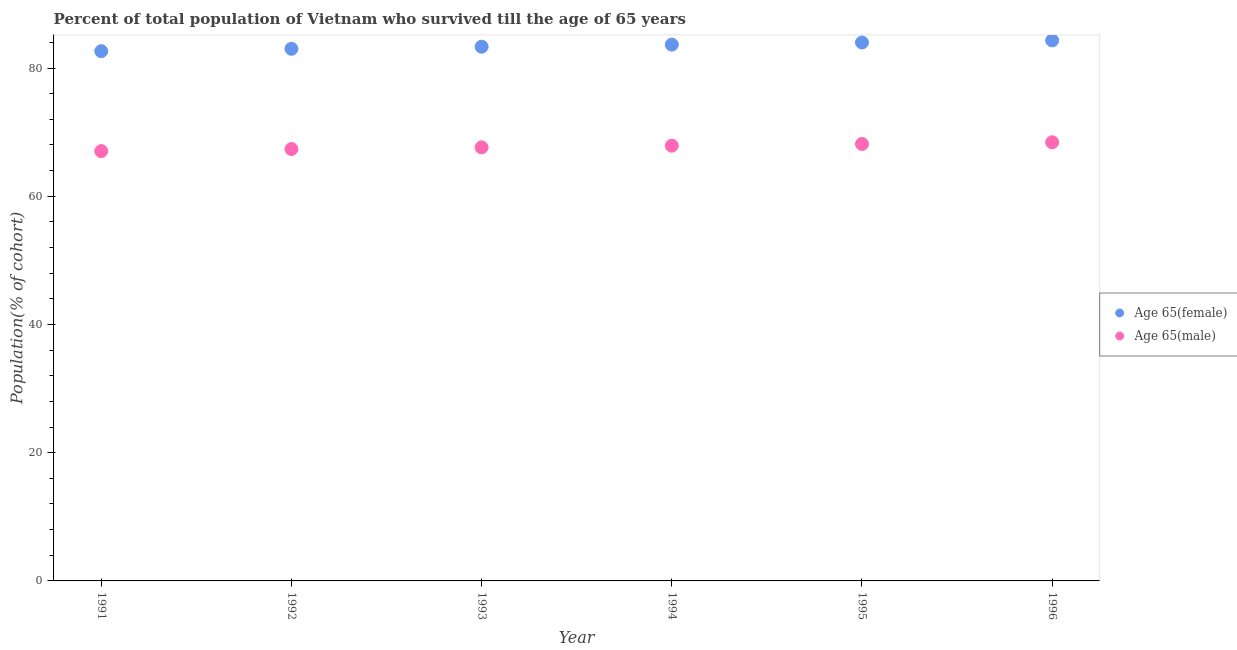Is the number of dotlines equal to the number of legend labels?
Keep it short and to the point. Yes. What is the percentage of female population who survived till age of 65 in 1995?
Your answer should be very brief. 83.99. Across all years, what is the maximum percentage of female population who survived till age of 65?
Make the answer very short. 84.31. Across all years, what is the minimum percentage of male population who survived till age of 65?
Your answer should be very brief. 67.05. In which year was the percentage of female population who survived till age of 65 maximum?
Keep it short and to the point. 1996. In which year was the percentage of female population who survived till age of 65 minimum?
Offer a very short reply. 1991. What is the total percentage of male population who survived till age of 65 in the graph?
Give a very brief answer. 406.53. What is the difference between the percentage of male population who survived till age of 65 in 1991 and that in 1995?
Provide a short and direct response. -1.11. What is the difference between the percentage of female population who survived till age of 65 in 1996 and the percentage of male population who survived till age of 65 in 1991?
Offer a terse response. 17.27. What is the average percentage of female population who survived till age of 65 per year?
Keep it short and to the point. 83.49. In the year 1996, what is the difference between the percentage of male population who survived till age of 65 and percentage of female population who survived till age of 65?
Ensure brevity in your answer.  -15.89. In how many years, is the percentage of male population who survived till age of 65 greater than 24 %?
Your response must be concise. 6. What is the ratio of the percentage of male population who survived till age of 65 in 1994 to that in 1996?
Your response must be concise. 0.99. Is the percentage of female population who survived till age of 65 in 1994 less than that in 1996?
Make the answer very short. Yes. Is the difference between the percentage of female population who survived till age of 65 in 1992 and 1995 greater than the difference between the percentage of male population who survived till age of 65 in 1992 and 1995?
Provide a short and direct response. No. What is the difference between the highest and the second highest percentage of male population who survived till age of 65?
Your response must be concise. 0.26. What is the difference between the highest and the lowest percentage of male population who survived till age of 65?
Your response must be concise. 1.38. Is the sum of the percentage of female population who survived till age of 65 in 1993 and 1996 greater than the maximum percentage of male population who survived till age of 65 across all years?
Your answer should be very brief. Yes. Is the percentage of male population who survived till age of 65 strictly less than the percentage of female population who survived till age of 65 over the years?
Keep it short and to the point. Yes. What is the difference between two consecutive major ticks on the Y-axis?
Give a very brief answer. 20. Are the values on the major ticks of Y-axis written in scientific E-notation?
Keep it short and to the point. No. Does the graph contain any zero values?
Keep it short and to the point. No. Does the graph contain grids?
Offer a terse response. No. How many legend labels are there?
Your answer should be compact. 2. What is the title of the graph?
Offer a very short reply. Percent of total population of Vietnam who survived till the age of 65 years. Does "Official aid received" appear as one of the legend labels in the graph?
Your answer should be compact. No. What is the label or title of the X-axis?
Make the answer very short. Year. What is the label or title of the Y-axis?
Offer a terse response. Population(% of cohort). What is the Population(% of cohort) of Age 65(female) in 1991?
Offer a terse response. 82.63. What is the Population(% of cohort) of Age 65(male) in 1991?
Ensure brevity in your answer.  67.05. What is the Population(% of cohort) in Age 65(female) in 1992?
Keep it short and to the point. 83. What is the Population(% of cohort) of Age 65(male) in 1992?
Your response must be concise. 67.37. What is the Population(% of cohort) in Age 65(female) in 1993?
Make the answer very short. 83.33. What is the Population(% of cohort) in Age 65(male) in 1993?
Provide a short and direct response. 67.63. What is the Population(% of cohort) in Age 65(female) in 1994?
Give a very brief answer. 83.66. What is the Population(% of cohort) in Age 65(male) in 1994?
Give a very brief answer. 67.9. What is the Population(% of cohort) in Age 65(female) in 1995?
Your response must be concise. 83.99. What is the Population(% of cohort) of Age 65(male) in 1995?
Keep it short and to the point. 68.16. What is the Population(% of cohort) of Age 65(female) in 1996?
Your response must be concise. 84.31. What is the Population(% of cohort) of Age 65(male) in 1996?
Offer a terse response. 68.42. Across all years, what is the maximum Population(% of cohort) of Age 65(female)?
Provide a short and direct response. 84.31. Across all years, what is the maximum Population(% of cohort) in Age 65(male)?
Ensure brevity in your answer.  68.42. Across all years, what is the minimum Population(% of cohort) of Age 65(female)?
Offer a very short reply. 82.63. Across all years, what is the minimum Population(% of cohort) in Age 65(male)?
Provide a short and direct response. 67.05. What is the total Population(% of cohort) of Age 65(female) in the graph?
Ensure brevity in your answer.  500.93. What is the total Population(% of cohort) of Age 65(male) in the graph?
Your answer should be compact. 406.53. What is the difference between the Population(% of cohort) of Age 65(female) in 1991 and that in 1992?
Make the answer very short. -0.37. What is the difference between the Population(% of cohort) in Age 65(male) in 1991 and that in 1992?
Make the answer very short. -0.32. What is the difference between the Population(% of cohort) in Age 65(female) in 1991 and that in 1993?
Provide a short and direct response. -0.7. What is the difference between the Population(% of cohort) in Age 65(male) in 1991 and that in 1993?
Your response must be concise. -0.58. What is the difference between the Population(% of cohort) in Age 65(female) in 1991 and that in 1994?
Offer a terse response. -1.02. What is the difference between the Population(% of cohort) of Age 65(male) in 1991 and that in 1994?
Offer a terse response. -0.85. What is the difference between the Population(% of cohort) in Age 65(female) in 1991 and that in 1995?
Your response must be concise. -1.35. What is the difference between the Population(% of cohort) of Age 65(male) in 1991 and that in 1995?
Offer a very short reply. -1.11. What is the difference between the Population(% of cohort) of Age 65(female) in 1991 and that in 1996?
Your response must be concise. -1.68. What is the difference between the Population(% of cohort) of Age 65(male) in 1991 and that in 1996?
Your answer should be very brief. -1.38. What is the difference between the Population(% of cohort) of Age 65(female) in 1992 and that in 1993?
Your answer should be very brief. -0.33. What is the difference between the Population(% of cohort) in Age 65(male) in 1992 and that in 1993?
Provide a short and direct response. -0.26. What is the difference between the Population(% of cohort) in Age 65(female) in 1992 and that in 1994?
Give a very brief answer. -0.66. What is the difference between the Population(% of cohort) in Age 65(male) in 1992 and that in 1994?
Your answer should be compact. -0.53. What is the difference between the Population(% of cohort) of Age 65(female) in 1992 and that in 1995?
Give a very brief answer. -0.98. What is the difference between the Population(% of cohort) in Age 65(male) in 1992 and that in 1995?
Offer a very short reply. -0.79. What is the difference between the Population(% of cohort) in Age 65(female) in 1992 and that in 1996?
Offer a terse response. -1.31. What is the difference between the Population(% of cohort) in Age 65(male) in 1992 and that in 1996?
Ensure brevity in your answer.  -1.06. What is the difference between the Population(% of cohort) in Age 65(female) in 1993 and that in 1994?
Your answer should be very brief. -0.33. What is the difference between the Population(% of cohort) of Age 65(male) in 1993 and that in 1994?
Keep it short and to the point. -0.26. What is the difference between the Population(% of cohort) in Age 65(female) in 1993 and that in 1995?
Provide a succinct answer. -0.66. What is the difference between the Population(% of cohort) of Age 65(male) in 1993 and that in 1995?
Keep it short and to the point. -0.53. What is the difference between the Population(% of cohort) of Age 65(female) in 1993 and that in 1996?
Provide a succinct answer. -0.98. What is the difference between the Population(% of cohort) in Age 65(male) in 1993 and that in 1996?
Your answer should be very brief. -0.79. What is the difference between the Population(% of cohort) in Age 65(female) in 1994 and that in 1995?
Ensure brevity in your answer.  -0.33. What is the difference between the Population(% of cohort) of Age 65(male) in 1994 and that in 1995?
Keep it short and to the point. -0.26. What is the difference between the Population(% of cohort) of Age 65(female) in 1994 and that in 1996?
Keep it short and to the point. -0.66. What is the difference between the Population(% of cohort) of Age 65(male) in 1994 and that in 1996?
Provide a short and direct response. -0.53. What is the difference between the Population(% of cohort) of Age 65(female) in 1995 and that in 1996?
Offer a very short reply. -0.33. What is the difference between the Population(% of cohort) of Age 65(male) in 1995 and that in 1996?
Your answer should be very brief. -0.26. What is the difference between the Population(% of cohort) of Age 65(female) in 1991 and the Population(% of cohort) of Age 65(male) in 1992?
Your answer should be compact. 15.27. What is the difference between the Population(% of cohort) in Age 65(female) in 1991 and the Population(% of cohort) in Age 65(male) in 1993?
Your answer should be compact. 15. What is the difference between the Population(% of cohort) in Age 65(female) in 1991 and the Population(% of cohort) in Age 65(male) in 1994?
Your response must be concise. 14.74. What is the difference between the Population(% of cohort) of Age 65(female) in 1991 and the Population(% of cohort) of Age 65(male) in 1995?
Ensure brevity in your answer.  14.47. What is the difference between the Population(% of cohort) in Age 65(female) in 1991 and the Population(% of cohort) in Age 65(male) in 1996?
Keep it short and to the point. 14.21. What is the difference between the Population(% of cohort) in Age 65(female) in 1992 and the Population(% of cohort) in Age 65(male) in 1993?
Make the answer very short. 15.37. What is the difference between the Population(% of cohort) in Age 65(female) in 1992 and the Population(% of cohort) in Age 65(male) in 1994?
Offer a very short reply. 15.11. What is the difference between the Population(% of cohort) of Age 65(female) in 1992 and the Population(% of cohort) of Age 65(male) in 1995?
Ensure brevity in your answer.  14.84. What is the difference between the Population(% of cohort) in Age 65(female) in 1992 and the Population(% of cohort) in Age 65(male) in 1996?
Your response must be concise. 14.58. What is the difference between the Population(% of cohort) of Age 65(female) in 1993 and the Population(% of cohort) of Age 65(male) in 1994?
Offer a very short reply. 15.44. What is the difference between the Population(% of cohort) in Age 65(female) in 1993 and the Population(% of cohort) in Age 65(male) in 1995?
Offer a terse response. 15.17. What is the difference between the Population(% of cohort) in Age 65(female) in 1993 and the Population(% of cohort) in Age 65(male) in 1996?
Provide a short and direct response. 14.91. What is the difference between the Population(% of cohort) of Age 65(female) in 1994 and the Population(% of cohort) of Age 65(male) in 1995?
Provide a short and direct response. 15.5. What is the difference between the Population(% of cohort) of Age 65(female) in 1994 and the Population(% of cohort) of Age 65(male) in 1996?
Make the answer very short. 15.23. What is the difference between the Population(% of cohort) in Age 65(female) in 1995 and the Population(% of cohort) in Age 65(male) in 1996?
Offer a very short reply. 15.56. What is the average Population(% of cohort) in Age 65(female) per year?
Your answer should be very brief. 83.49. What is the average Population(% of cohort) of Age 65(male) per year?
Provide a succinct answer. 67.75. In the year 1991, what is the difference between the Population(% of cohort) of Age 65(female) and Population(% of cohort) of Age 65(male)?
Offer a terse response. 15.59. In the year 1992, what is the difference between the Population(% of cohort) in Age 65(female) and Population(% of cohort) in Age 65(male)?
Ensure brevity in your answer.  15.64. In the year 1993, what is the difference between the Population(% of cohort) of Age 65(female) and Population(% of cohort) of Age 65(male)?
Provide a short and direct response. 15.7. In the year 1994, what is the difference between the Population(% of cohort) in Age 65(female) and Population(% of cohort) in Age 65(male)?
Your response must be concise. 15.76. In the year 1995, what is the difference between the Population(% of cohort) of Age 65(female) and Population(% of cohort) of Age 65(male)?
Make the answer very short. 15.83. In the year 1996, what is the difference between the Population(% of cohort) of Age 65(female) and Population(% of cohort) of Age 65(male)?
Provide a short and direct response. 15.89. What is the ratio of the Population(% of cohort) in Age 65(female) in 1991 to that in 1992?
Provide a succinct answer. 1. What is the ratio of the Population(% of cohort) of Age 65(male) in 1991 to that in 1994?
Ensure brevity in your answer.  0.99. What is the ratio of the Population(% of cohort) in Age 65(female) in 1991 to that in 1995?
Offer a very short reply. 0.98. What is the ratio of the Population(% of cohort) of Age 65(male) in 1991 to that in 1995?
Your response must be concise. 0.98. What is the ratio of the Population(% of cohort) of Age 65(female) in 1991 to that in 1996?
Ensure brevity in your answer.  0.98. What is the ratio of the Population(% of cohort) in Age 65(male) in 1991 to that in 1996?
Make the answer very short. 0.98. What is the ratio of the Population(% of cohort) in Age 65(male) in 1992 to that in 1994?
Offer a very short reply. 0.99. What is the ratio of the Population(% of cohort) of Age 65(female) in 1992 to that in 1995?
Your answer should be very brief. 0.99. What is the ratio of the Population(% of cohort) in Age 65(male) in 1992 to that in 1995?
Keep it short and to the point. 0.99. What is the ratio of the Population(% of cohort) in Age 65(female) in 1992 to that in 1996?
Make the answer very short. 0.98. What is the ratio of the Population(% of cohort) in Age 65(male) in 1992 to that in 1996?
Your answer should be very brief. 0.98. What is the ratio of the Population(% of cohort) in Age 65(female) in 1993 to that in 1994?
Make the answer very short. 1. What is the ratio of the Population(% of cohort) in Age 65(female) in 1993 to that in 1996?
Ensure brevity in your answer.  0.99. What is the ratio of the Population(% of cohort) in Age 65(male) in 1993 to that in 1996?
Give a very brief answer. 0.99. What is the ratio of the Population(% of cohort) in Age 65(male) in 1994 to that in 1995?
Make the answer very short. 1. What is the difference between the highest and the second highest Population(% of cohort) of Age 65(female)?
Your response must be concise. 0.33. What is the difference between the highest and the second highest Population(% of cohort) of Age 65(male)?
Offer a very short reply. 0.26. What is the difference between the highest and the lowest Population(% of cohort) in Age 65(female)?
Offer a terse response. 1.68. What is the difference between the highest and the lowest Population(% of cohort) in Age 65(male)?
Your answer should be compact. 1.38. 